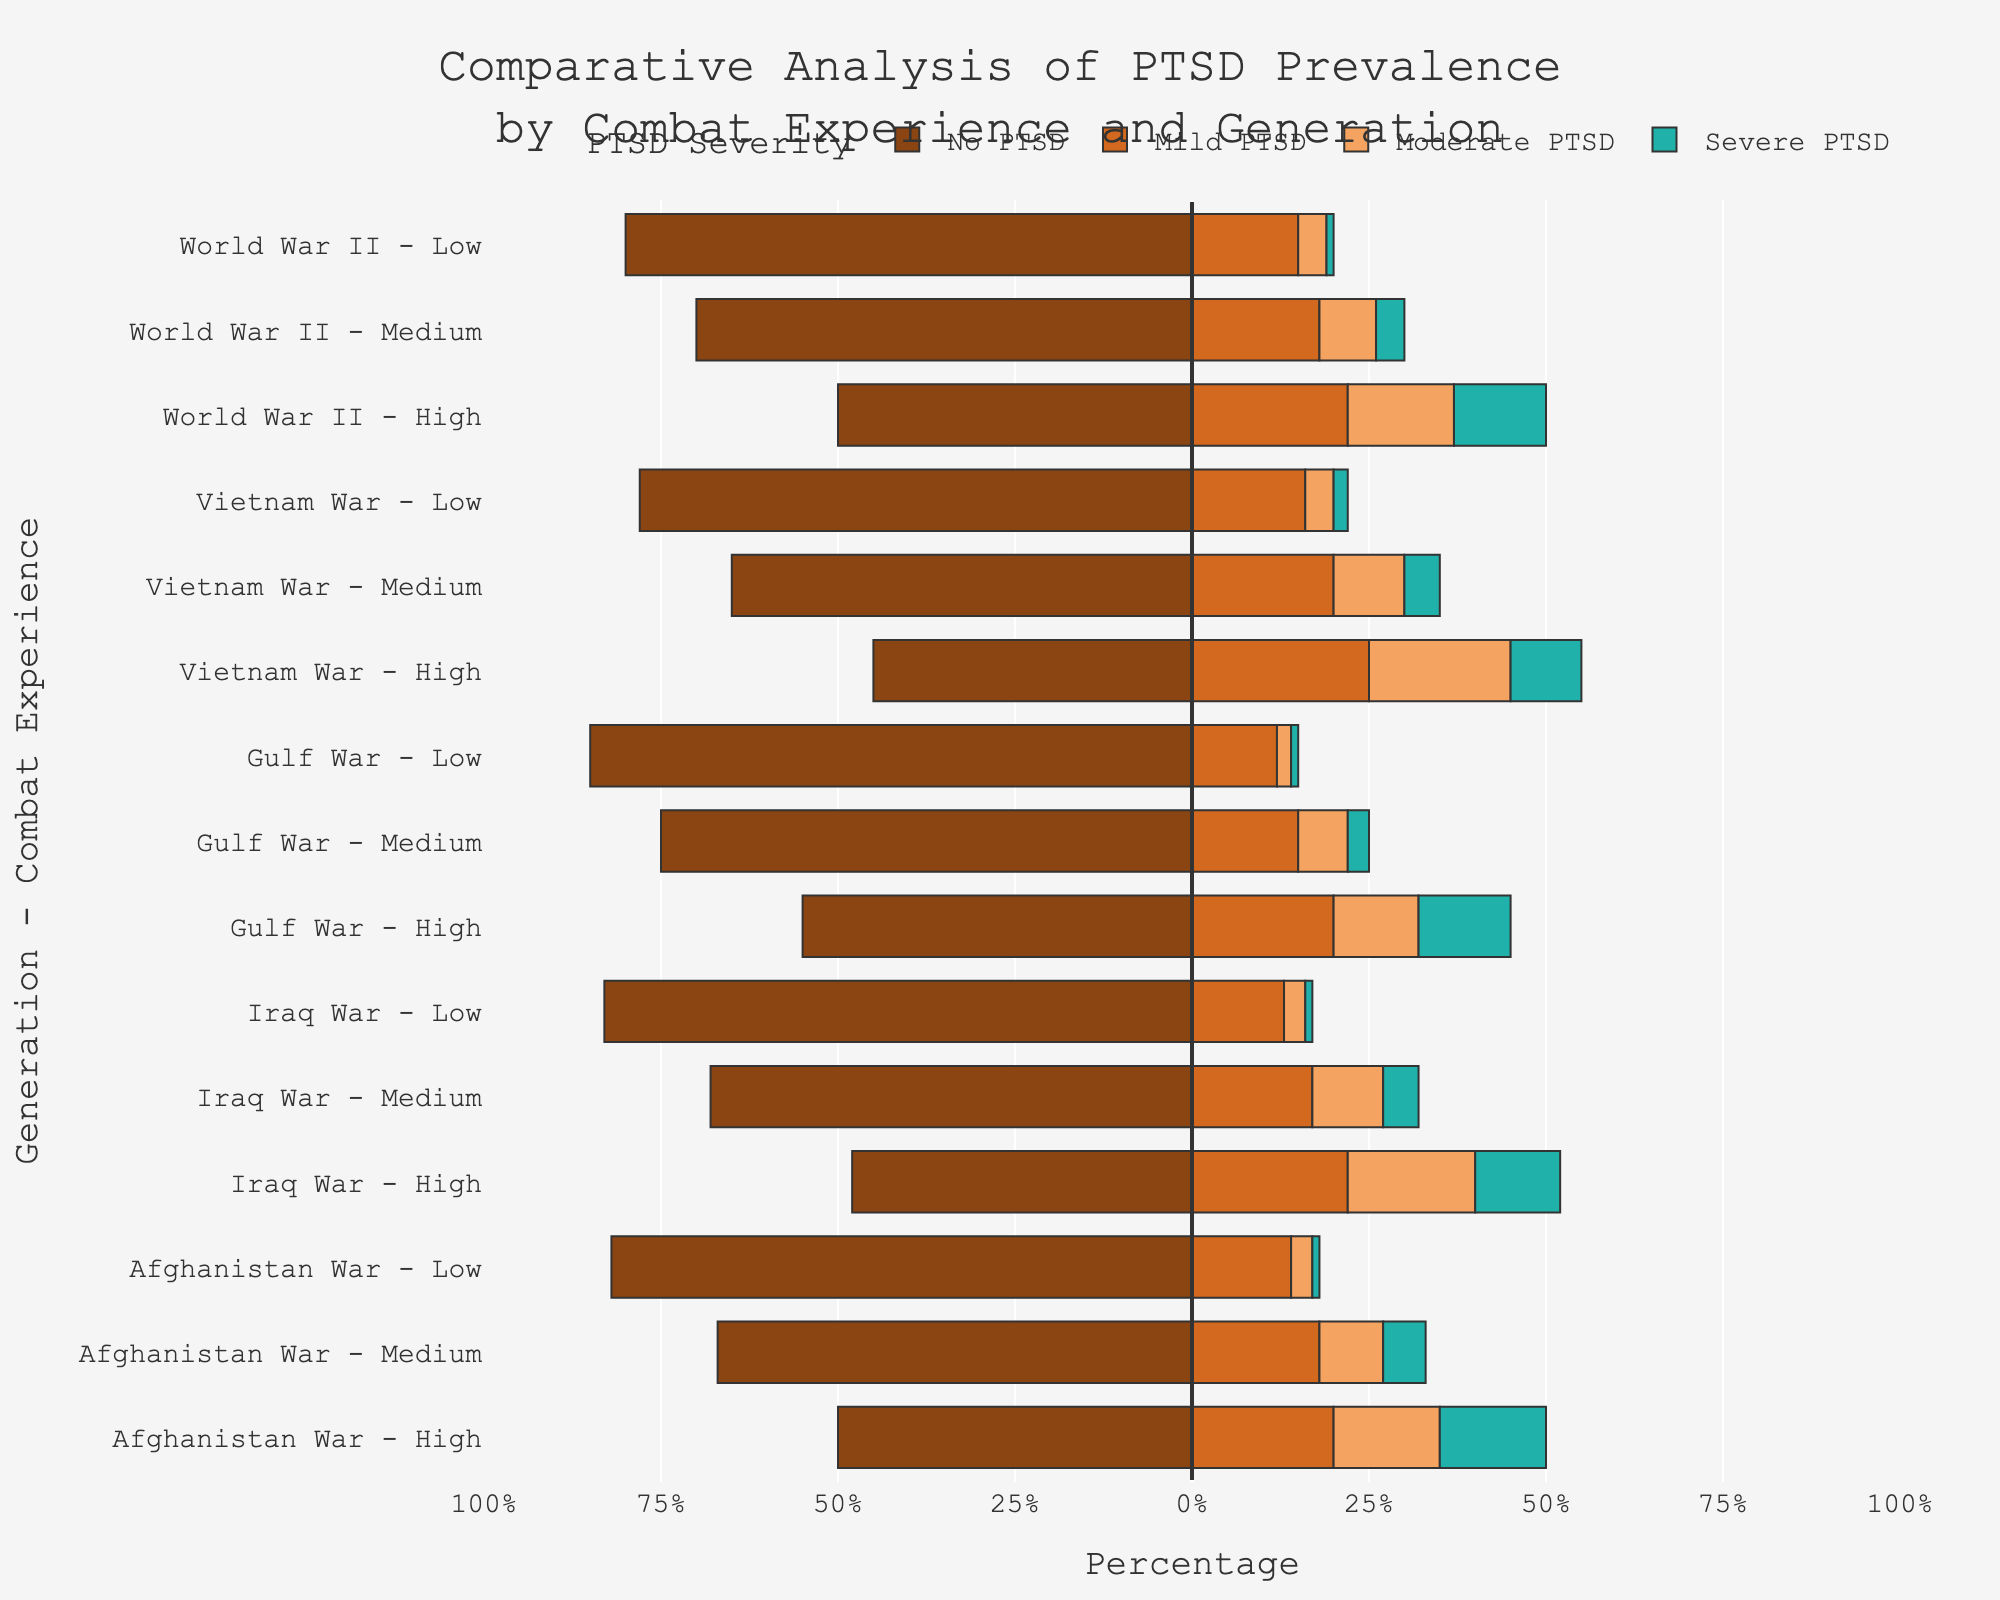What's the generation with the highest percentage of severe PTSD among those with high combat experience? To determine the generation with the highest percentage of severe PTSD among those with high combat experience, we look for the longest bar section corresponding to severe PTSD in the high combat experience category for each generation. Comparing all generations, Afghanistan War shows the highest severity with 15%.
Answer: Afghanistan War How does the proportion of moderate PTSD in high combat experience for the Vietnam War compare to the World War II generation with high combat experience? For the Vietnam War, high combat experience shows a moderate PTSD percentage of 20%. For World War II with high combat experience, the moderate PTSD percentage is 15%. By comparing these values, Vietnam War generation has a 5% higher moderate PTSD rate than World War II.
Answer: Vietnam War has 5% higher What's the sum of the mild and moderate PTSD percentages for the Gulf War generation with medium combat experience? For the Gulf War generation with medium combat experience, the mild PTSD percentage is 15% and the moderate PTSD percentage is 7%. Adding these together: 15% + 7% = 22%
Answer: 22% In which generation and combat experience bracket is the percentage of 'No PTSD' closest to 65%? We find the closest value to 65% in the 'No PTSD' category, which can be found in the Vietnam War generation with medium combat experience having a no PTSD percentage of 65%.
Answer: Vietnam War Medium How does the distribution of PTSD levels differ between those with low combat experience in World War II and the Gulf War? For World War II with low combat experience: No PTSD is 80%, Mild PTSD is 15%, Moderate PTSD is 4%, Severe PTSD is 1%. For the Gulf War with low combat experience: No PTSD is 85%, Mild PTSD is 12%, Moderate PTSD is 2%, Severe PTSD is 1%. Compare these, we observe Gulf War has a higher no PTSD but lower mild and moderate PTSD percentages.
Answer: Gulf War: Higher No PTSD, Lower Mild and Moderate PTSD Which combat experience level in the Iraq War has the least percentage of severe PTSD? For the Iraq War, low combat experience has a severe PTSD percentage of 1%, medium combat experience is 5%, and high combat experience is 12%. The lowest percentage is in the low combat experience category.
Answer: Low What's the average PTSD percentage (combining mild, moderate, and severe) in high combat experience for all the wars combined? First, we sum the mild, moderate, and severe PTSD percentages for high combat experience across all wars: World War II (22+15+13=50%), Vietnam War (25+20+10=55%), Gulf War (20+12+13=45%), Iraq War (22+18+12=52%), and Afghanistan War (20+15+15=50%). Then we average these sums: (50+55+45+52+50)/5 = 50.4%
Answer: 50.4% Which generation has the least variance in PTSD levels (mild, moderate, severe) for low combat experience? To determine this, we compare the spread of percentages across mild, moderate, and severe PTSD for each generation in the low combat experience bracket. The Gulf War generation shows the smallest differences between PTSD levels (12%, 2%, 1%) than others.
Answer: Gulf War 